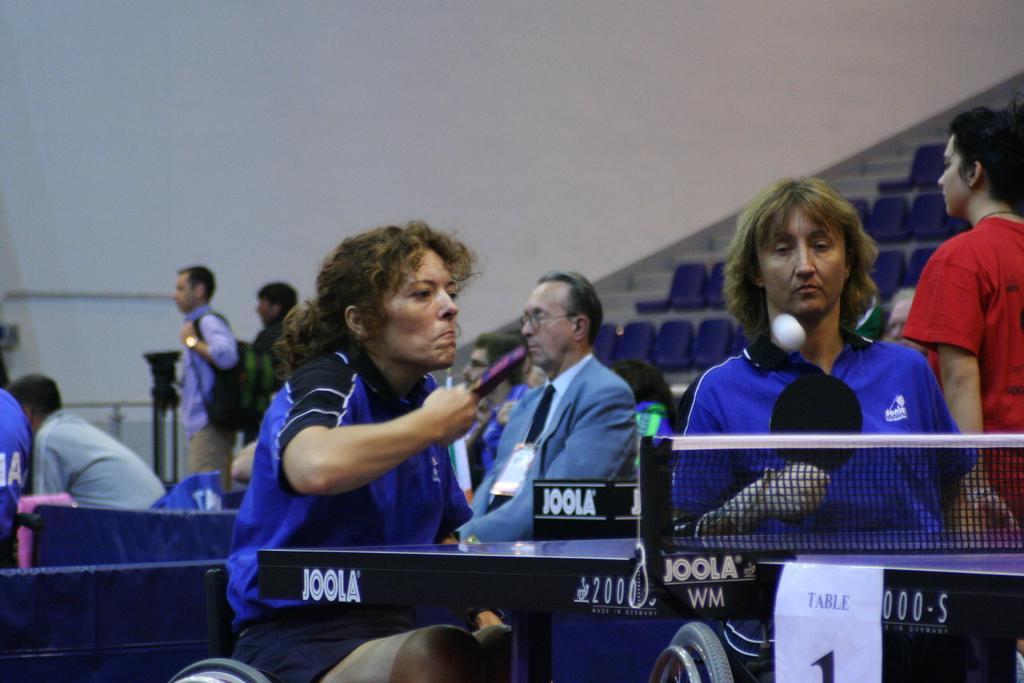In one or two sentences, can you explain what this image depicts? In the picture we can see these people wearing blue color dresses are holding rackets in the hands and playing table tennis. Here we can see the table tennis table and here we can see the ball in the air. In the background, we can see a few more people we can see chairs in the stadium and the wall. 